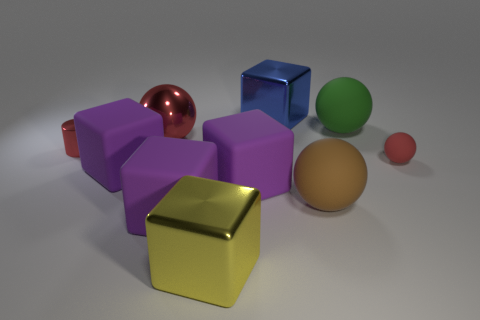There is a metallic thing that is in front of the small metal cylinder that is in front of the large blue shiny object; how big is it?
Make the answer very short. Large. There is another metallic thing that is the same shape as the large brown object; what is its color?
Your answer should be compact. Red. How many big shiny spheres have the same color as the small sphere?
Provide a succinct answer. 1. Does the yellow metal block have the same size as the metal cylinder?
Your answer should be compact. No. What is the brown sphere made of?
Offer a terse response. Rubber. The tiny cylinder that is the same material as the large red ball is what color?
Your response must be concise. Red. Are the tiny cylinder and the small red thing that is right of the cylinder made of the same material?
Ensure brevity in your answer.  No. What number of small red cylinders have the same material as the big green thing?
Make the answer very short. 0. What is the shape of the large rubber thing behind the tiny cylinder?
Offer a terse response. Sphere. Is the material of the green object behind the small shiny cylinder the same as the big brown sphere in front of the big green sphere?
Your answer should be very brief. Yes. 